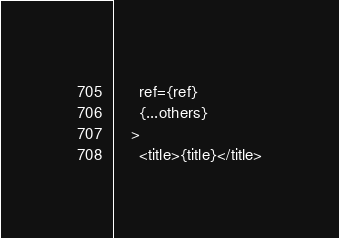Convert code to text. <code><loc_0><loc_0><loc_500><loc_500><_TypeScript_>      ref={ref}
      {...others}
    >
      <title>{title}</title></code> 